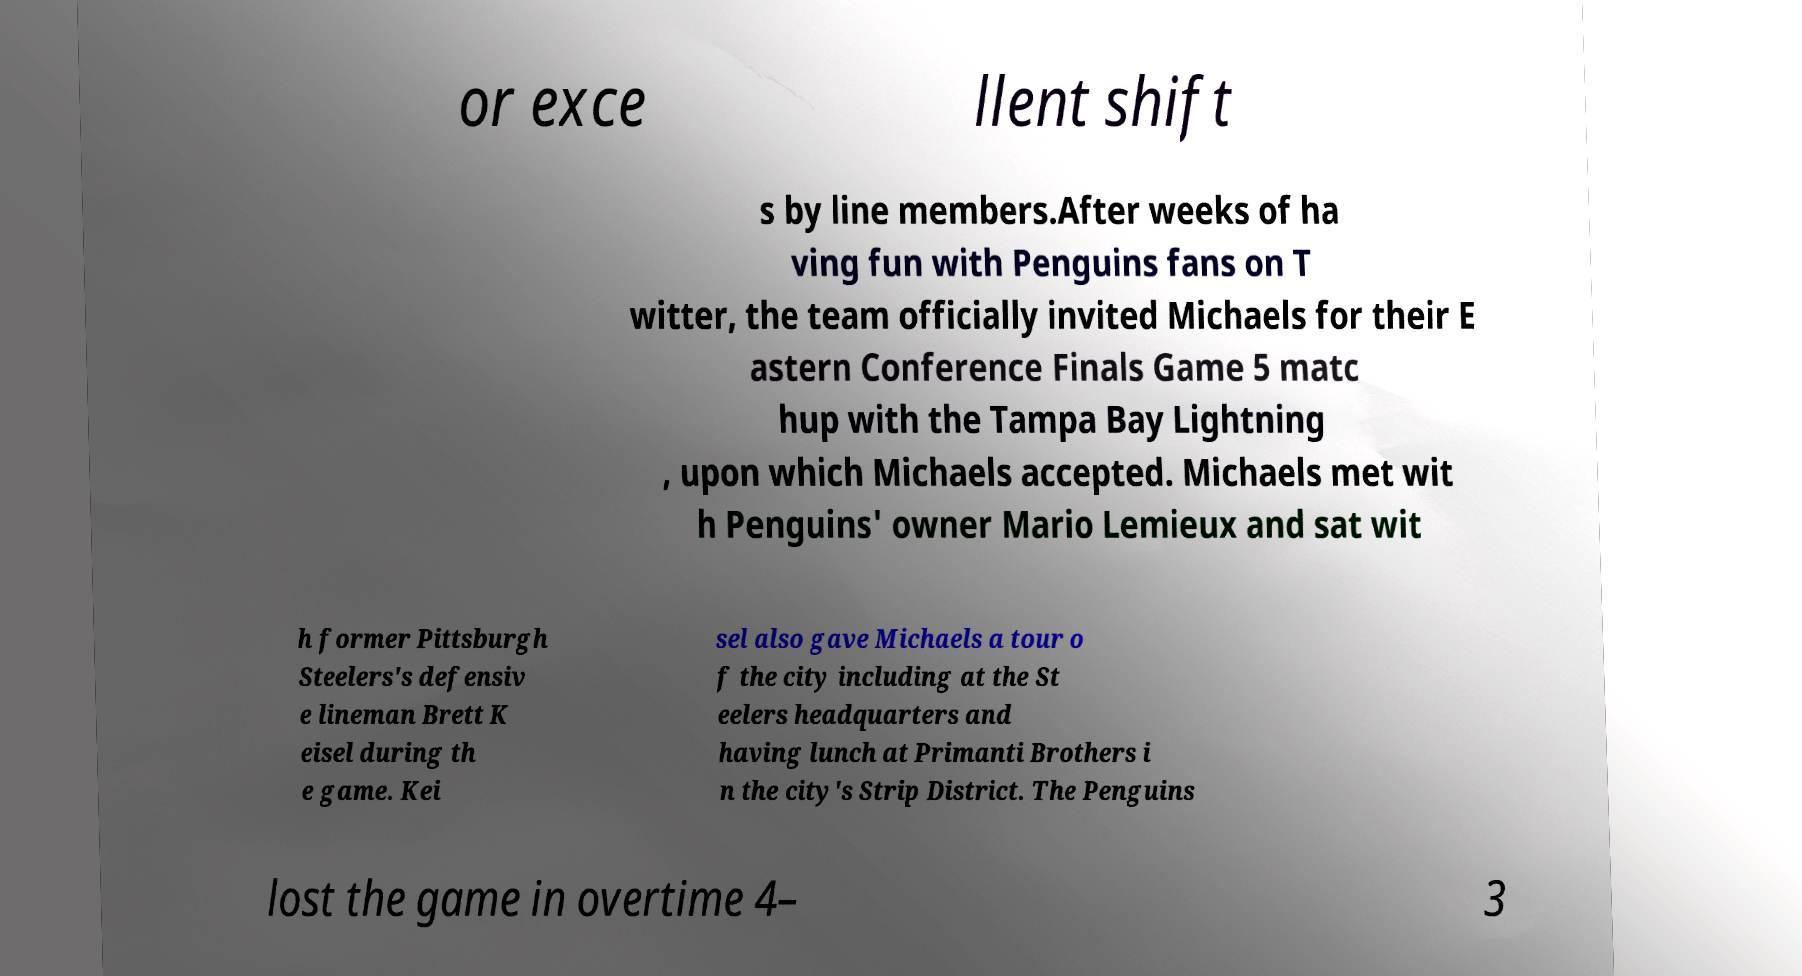Could you assist in decoding the text presented in this image and type it out clearly? or exce llent shift s by line members.After weeks of ha ving fun with Penguins fans on T witter, the team officially invited Michaels for their E astern Conference Finals Game 5 matc hup with the Tampa Bay Lightning , upon which Michaels accepted. Michaels met wit h Penguins' owner Mario Lemieux and sat wit h former Pittsburgh Steelers's defensiv e lineman Brett K eisel during th e game. Kei sel also gave Michaels a tour o f the city including at the St eelers headquarters and having lunch at Primanti Brothers i n the city's Strip District. The Penguins lost the game in overtime 4– 3 